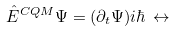Convert formula to latex. <formula><loc_0><loc_0><loc_500><loc_500>\hat { E } ^ { C Q M } \Psi = ( \partial _ { t } \Psi ) i \hbar { \, } \leftrightarrow \,</formula> 